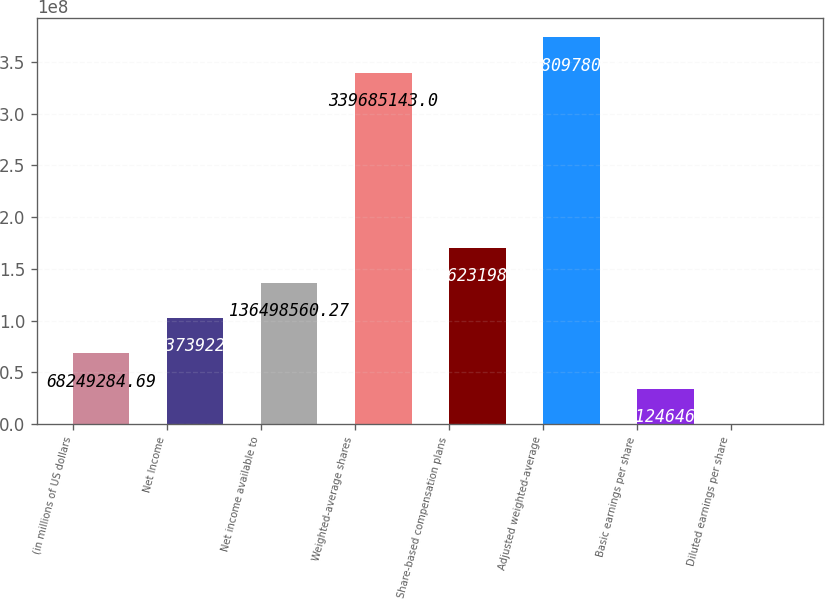Convert chart to OTSL. <chart><loc_0><loc_0><loc_500><loc_500><bar_chart><fcel>(in millions of US dollars<fcel>Net Income<fcel>Net income available to<fcel>Weighted-average shares<fcel>Share-based compensation plans<fcel>Adjusted weighted-average<fcel>Basic earnings per share<fcel>Diluted earnings per share<nl><fcel>6.82493e+07<fcel>1.02374e+08<fcel>1.36499e+08<fcel>3.39685e+08<fcel>1.70623e+08<fcel>3.7381e+08<fcel>3.41246e+07<fcel>9.11<nl></chart> 